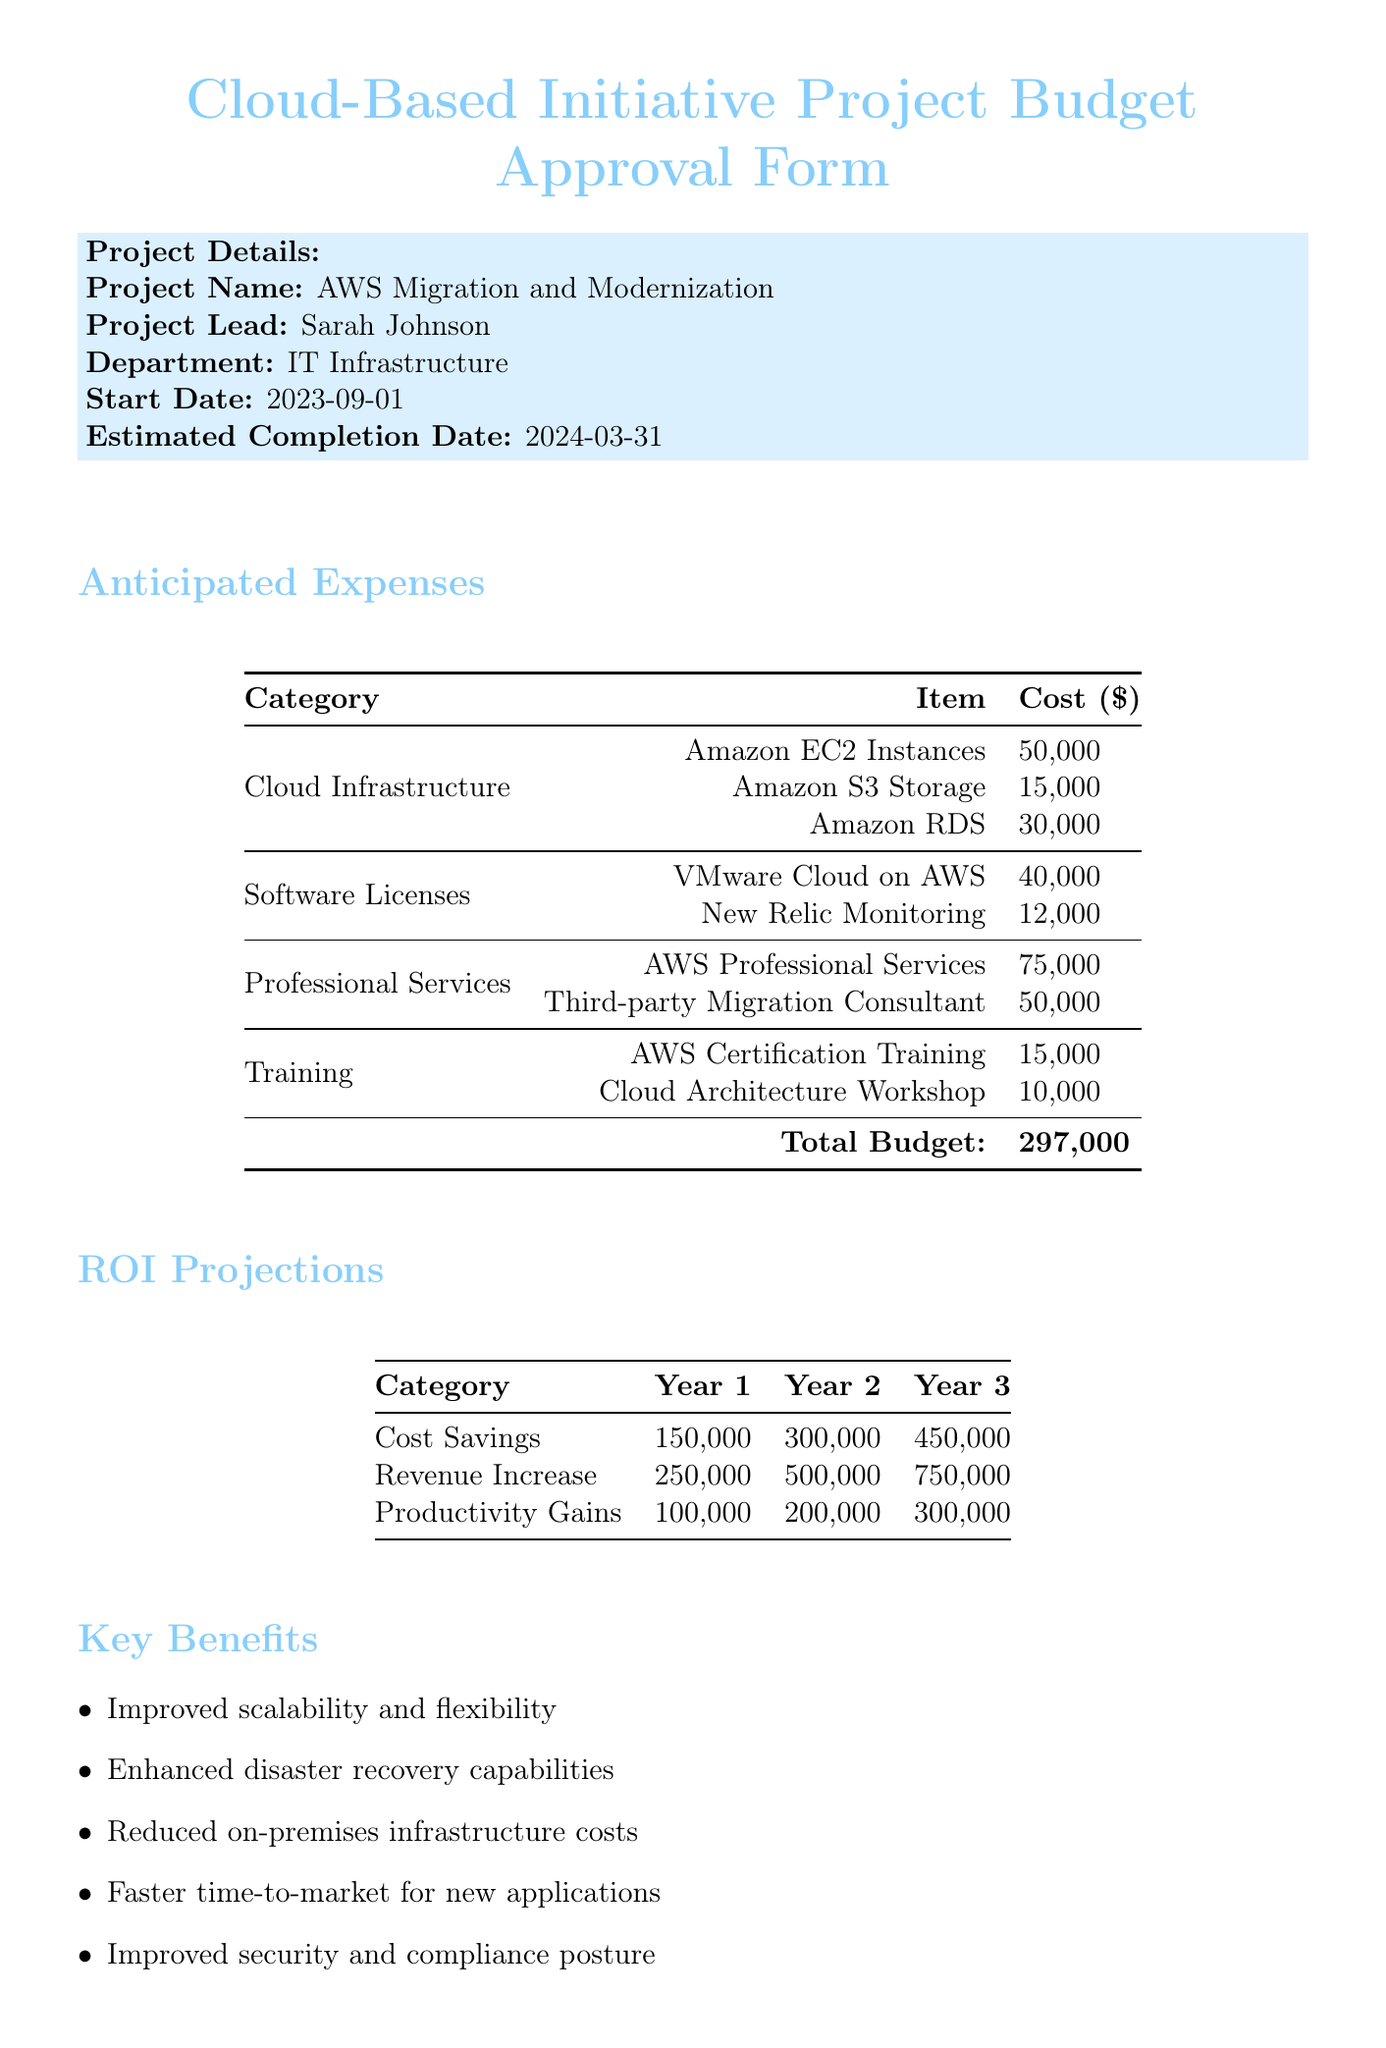What is the project name? The project name is listed in the project details section of the document.
Answer: AWS Migration and Modernization What is the total budget for the project? The total budget is provided under the anticipated expenses section of the document.
Answer: 297000 Who is the project lead? The project lead is specified in the project details section of the document.
Answer: Sarah Johnson What is the estimated completion date? The estimated completion date can be found in the project details section of the document.
Answer: 2024-03-31 How much is allocated for Amazon EC2 Instances? The cost for Amazon EC2 Instances is detailed under the cloud infrastructure expense category.
Answer: 50000 What is the projected revenue increase in year two? The projected revenue increase for year two is listed in the ROI projections table.
Answer: 500000 What are two key benefits of the project? Key benefits are listed in the key benefits section of the document.
Answer: Improved scalability and flexibility, Enhanced disaster recovery capabilities What is one risk associated with the project? Risks are outlined in the risks and mitigation strategies section of the document.
Answer: Data migration complexities Who is the CEO approving the project? The CEO's name is provided in the approval section of the document.
Answer: David Thompson 